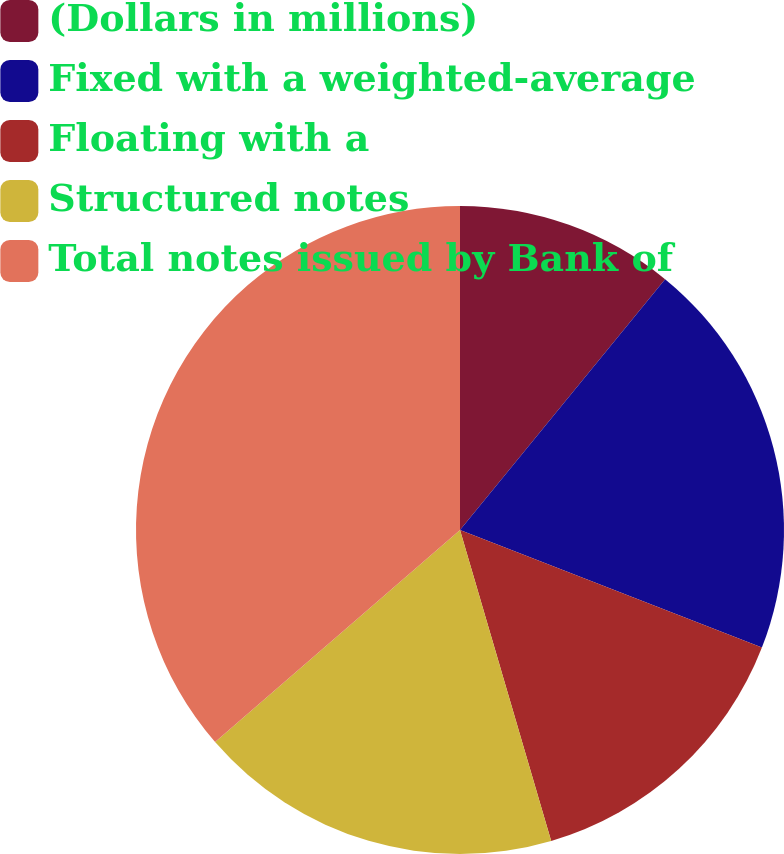<chart> <loc_0><loc_0><loc_500><loc_500><pie_chart><fcel>(Dollars in millions)<fcel>Fixed with a weighted-average<fcel>Floating with a<fcel>Structured notes<fcel>Total notes issued by Bank of<nl><fcel>10.91%<fcel>20.0%<fcel>14.55%<fcel>18.18%<fcel>36.36%<nl></chart> 